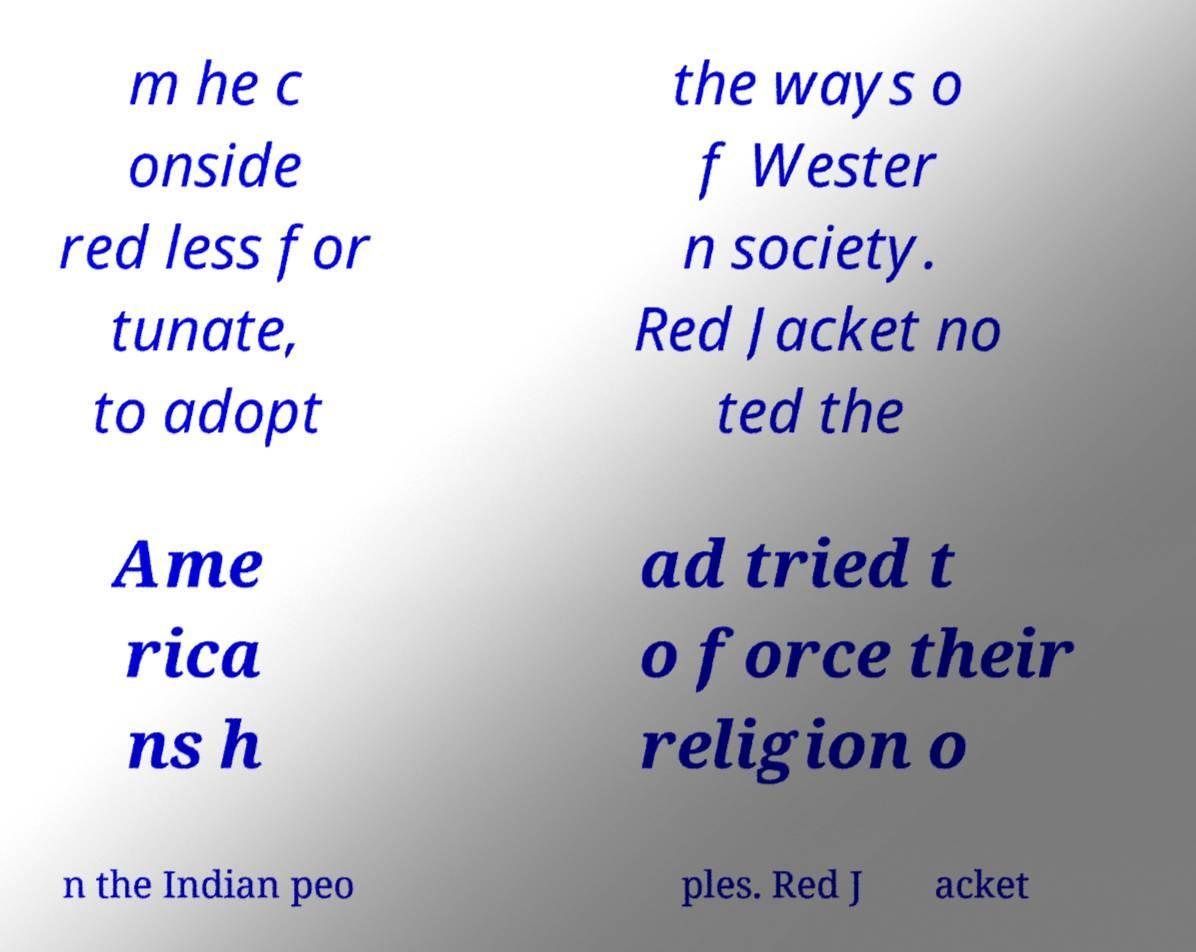Can you accurately transcribe the text from the provided image for me? m he c onside red less for tunate, to adopt the ways o f Wester n society. Red Jacket no ted the Ame rica ns h ad tried t o force their religion o n the Indian peo ples. Red J acket 